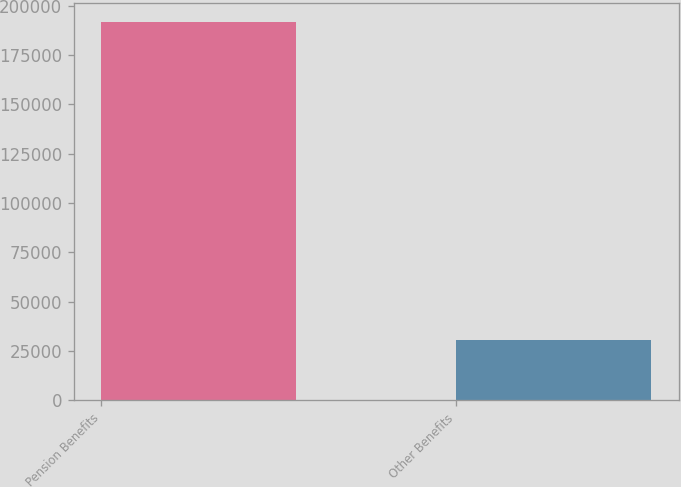Convert chart. <chart><loc_0><loc_0><loc_500><loc_500><bar_chart><fcel>Pension Benefits<fcel>Other Benefits<nl><fcel>191593<fcel>30399<nl></chart> 